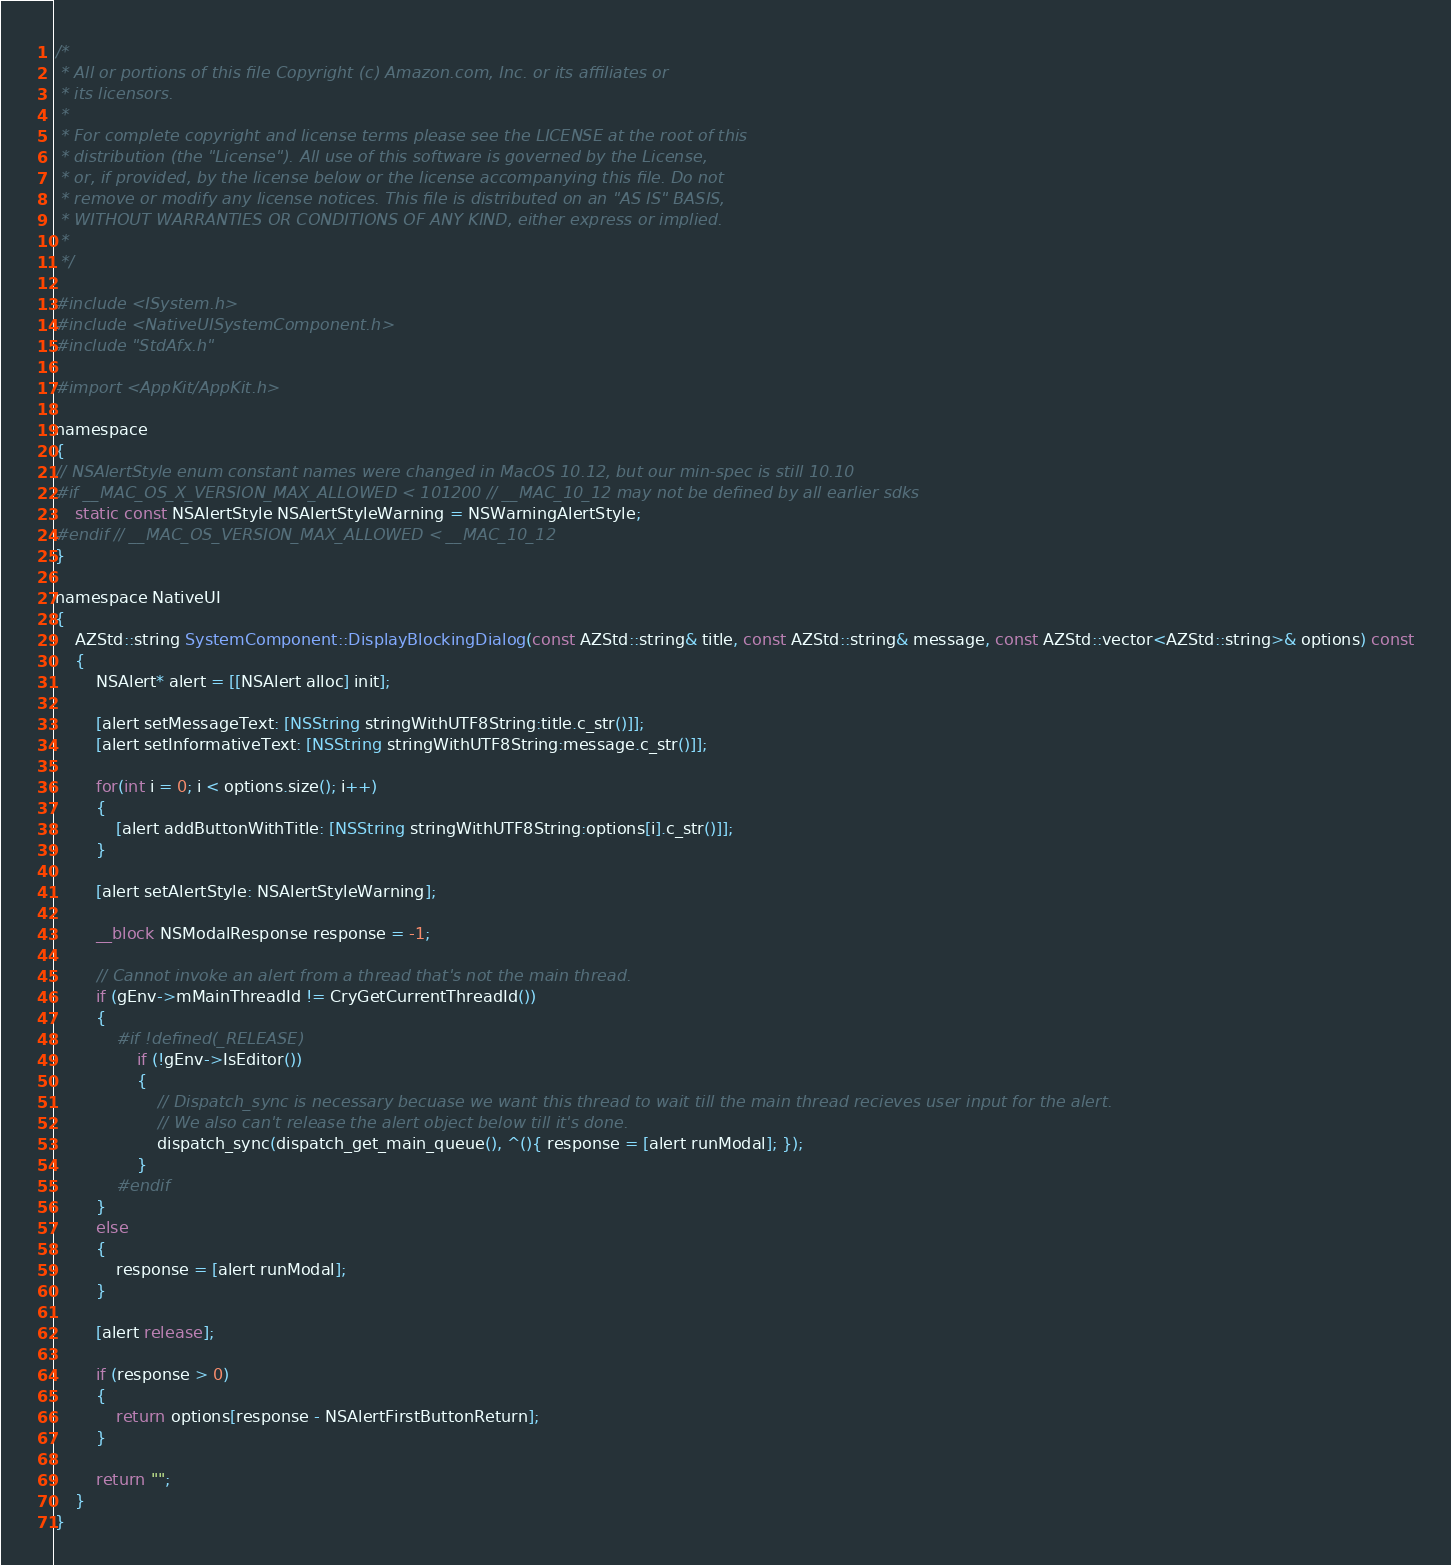<code> <loc_0><loc_0><loc_500><loc_500><_ObjectiveC_>/*
 * All or portions of this file Copyright (c) Amazon.com, Inc. or its affiliates or
 * its licensors.
 *
 * For complete copyright and license terms please see the LICENSE at the root of this
 * distribution (the "License"). All use of this software is governed by the License,
 * or, if provided, by the license below or the license accompanying this file. Do not
 * remove or modify any license notices. This file is distributed on an "AS IS" BASIS,
 * WITHOUT WARRANTIES OR CONDITIONS OF ANY KIND, either express or implied.
 *
 */

#include <ISystem.h>
#include <NativeUISystemComponent.h>
#include "StdAfx.h"

#import <AppKit/AppKit.h>

namespace
{
// NSAlertStyle enum constant names were changed in MacOS 10.12, but our min-spec is still 10.10
#if __MAC_OS_X_VERSION_MAX_ALLOWED < 101200 // __MAC_10_12 may not be defined by all earlier sdks
    static const NSAlertStyle NSAlertStyleWarning = NSWarningAlertStyle;
#endif // __MAC_OS_VERSION_MAX_ALLOWED < __MAC_10_12
}

namespace NativeUI
{
    AZStd::string SystemComponent::DisplayBlockingDialog(const AZStd::string& title, const AZStd::string& message, const AZStd::vector<AZStd::string>& options) const
    {
        NSAlert* alert = [[NSAlert alloc] init];
        
        [alert setMessageText: [NSString stringWithUTF8String:title.c_str()]];
        [alert setInformativeText: [NSString stringWithUTF8String:message.c_str()]];
        
        for(int i = 0; i < options.size(); i++)
        {
            [alert addButtonWithTitle: [NSString stringWithUTF8String:options[i].c_str()]];
        }
        
        [alert setAlertStyle: NSAlertStyleWarning];
        
        __block NSModalResponse response = -1;
        
        // Cannot invoke an alert from a thread that's not the main thread.
        if (gEnv->mMainThreadId != CryGetCurrentThreadId())
        {
            #if !defined(_RELEASE)
                if (!gEnv->IsEditor())
                {
                    // Dispatch_sync is necessary becuase we want this thread to wait till the main thread recieves user input for the alert.
                    // We also can't release the alert object below till it's done.
                    dispatch_sync(dispatch_get_main_queue(), ^(){ response = [alert runModal]; });
                }
            #endif
        }
        else
        {
            response = [alert runModal];
        }
        
        [alert release];
        
        if (response > 0)
        {
            return options[response - NSAlertFirstButtonReturn];
        }
        
        return "";
    }
}
</code> 